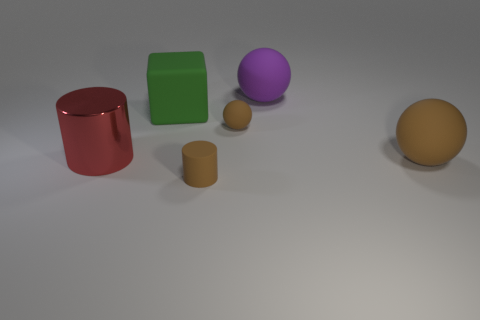Subtract all cyan blocks. Subtract all purple balls. How many blocks are left? 1 Add 2 big brown balls. How many objects exist? 8 Subtract all blocks. How many objects are left? 5 Subtract 0 green cylinders. How many objects are left? 6 Subtract all small brown matte cylinders. Subtract all big blocks. How many objects are left? 4 Add 3 big matte objects. How many big matte objects are left? 6 Add 1 green rubber blocks. How many green rubber blocks exist? 2 